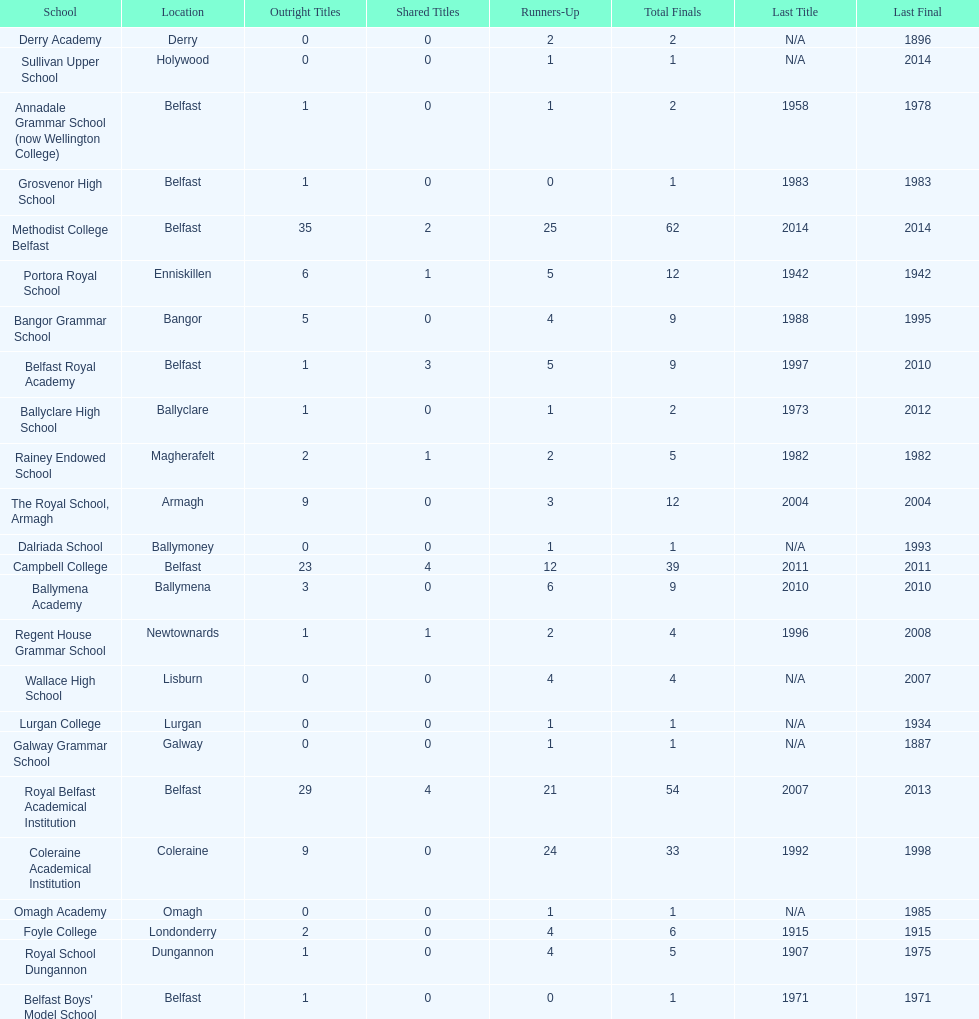What was the last year that the regent house grammar school won a title? 1996. 